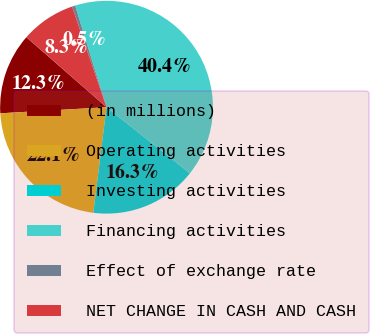Convert chart to OTSL. <chart><loc_0><loc_0><loc_500><loc_500><pie_chart><fcel>(in millions)<fcel>Operating activities<fcel>Investing activities<fcel>Financing activities<fcel>Effect of exchange rate<fcel>NET CHANGE IN CASH AND CASH<nl><fcel>12.33%<fcel>22.11%<fcel>16.32%<fcel>40.43%<fcel>0.48%<fcel>8.33%<nl></chart> 